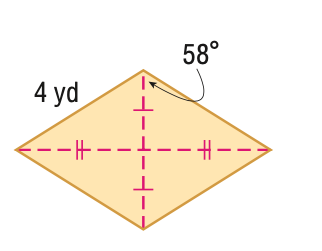Answer the mathemtical geometry problem and directly provide the correct option letter.
Question: Find the area of the figure in feet. Round to the nearest tenth, if necessary.
Choices: A: 14.4 B: 16 C: 28.8 D: 32 A 